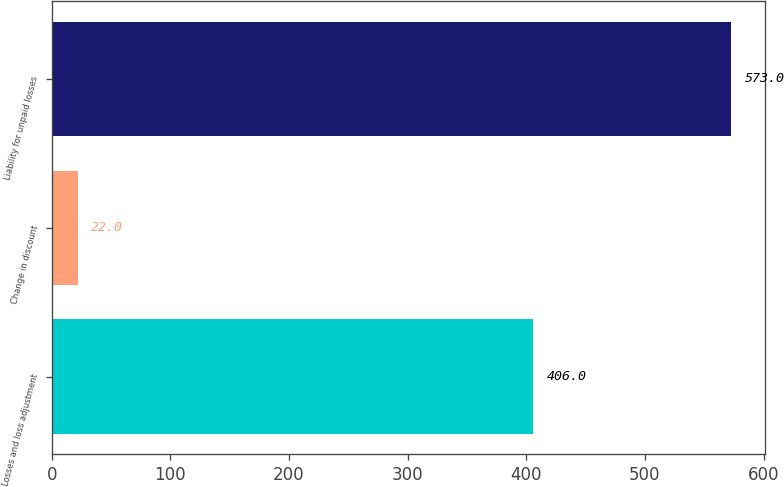<chart> <loc_0><loc_0><loc_500><loc_500><bar_chart><fcel>Losses and loss adjustment<fcel>Change in discount<fcel>Liability for unpaid losses<nl><fcel>406<fcel>22<fcel>573<nl></chart> 